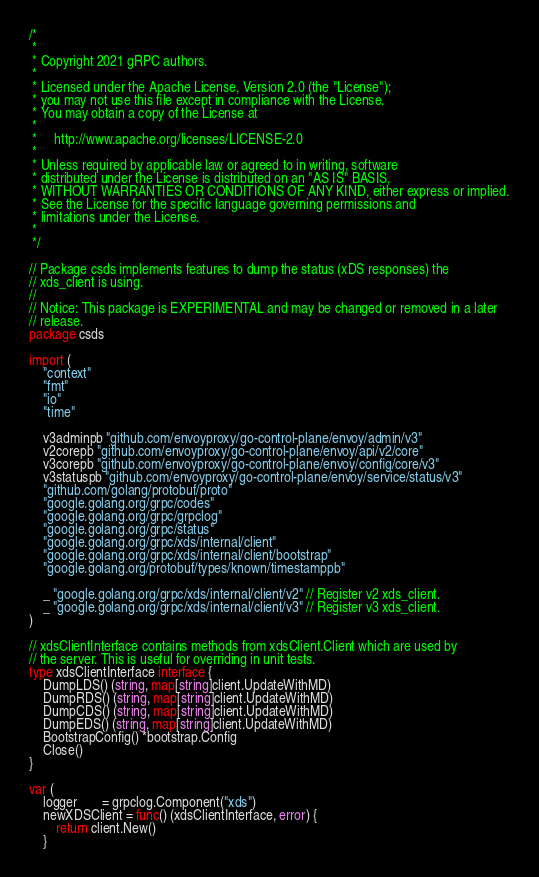<code> <loc_0><loc_0><loc_500><loc_500><_Go_>/*
 *
 * Copyright 2021 gRPC authors.
 *
 * Licensed under the Apache License, Version 2.0 (the "License");
 * you may not use this file except in compliance with the License.
 * You may obtain a copy of the License at
 *
 *     http://www.apache.org/licenses/LICENSE-2.0
 *
 * Unless required by applicable law or agreed to in writing, software
 * distributed under the License is distributed on an "AS IS" BASIS,
 * WITHOUT WARRANTIES OR CONDITIONS OF ANY KIND, either express or implied.
 * See the License for the specific language governing permissions and
 * limitations under the License.
 *
 */

// Package csds implements features to dump the status (xDS responses) the
// xds_client is using.
//
// Notice: This package is EXPERIMENTAL and may be changed or removed in a later
// release.
package csds

import (
	"context"
	"fmt"
	"io"
	"time"

	v3adminpb "github.com/envoyproxy/go-control-plane/envoy/admin/v3"
	v2corepb "github.com/envoyproxy/go-control-plane/envoy/api/v2/core"
	v3corepb "github.com/envoyproxy/go-control-plane/envoy/config/core/v3"
	v3statuspb "github.com/envoyproxy/go-control-plane/envoy/service/status/v3"
	"github.com/golang/protobuf/proto"
	"google.golang.org/grpc/codes"
	"google.golang.org/grpc/grpclog"
	"google.golang.org/grpc/status"
	"google.golang.org/grpc/xds/internal/client"
	"google.golang.org/grpc/xds/internal/client/bootstrap"
	"google.golang.org/protobuf/types/known/timestamppb"

	_ "google.golang.org/grpc/xds/internal/client/v2" // Register v2 xds_client.
	_ "google.golang.org/grpc/xds/internal/client/v3" // Register v3 xds_client.
)

// xdsClientInterface contains methods from xdsClient.Client which are used by
// the server. This is useful for overriding in unit tests.
type xdsClientInterface interface {
	DumpLDS() (string, map[string]client.UpdateWithMD)
	DumpRDS() (string, map[string]client.UpdateWithMD)
	DumpCDS() (string, map[string]client.UpdateWithMD)
	DumpEDS() (string, map[string]client.UpdateWithMD)
	BootstrapConfig() *bootstrap.Config
	Close()
}

var (
	logger       = grpclog.Component("xds")
	newXDSClient = func() (xdsClientInterface, error) {
		return client.New()
	}</code> 